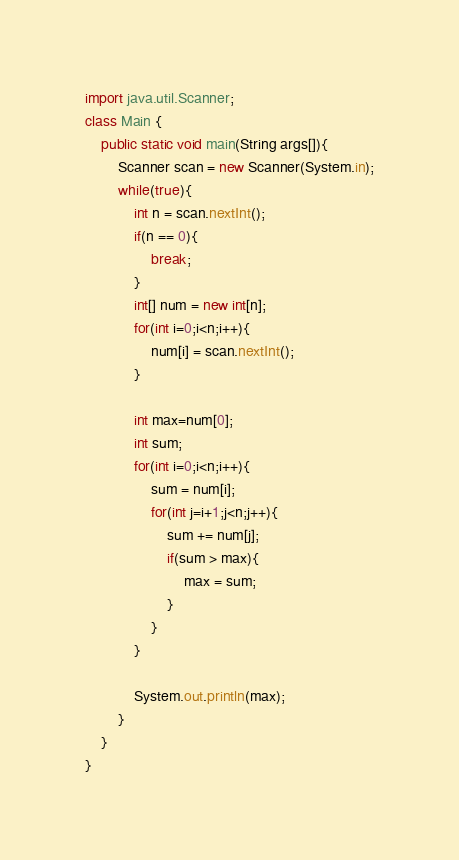<code> <loc_0><loc_0><loc_500><loc_500><_Java_>import java.util.Scanner;
class Main {
	public static void main(String args[]){
		Scanner scan = new Scanner(System.in);
		while(true){
			int n = scan.nextInt();
			if(n == 0){
				break;
			}
			int[] num = new int[n];
			for(int i=0;i<n;i++){
				num[i] = scan.nextInt();
			}
			
			int max=num[0];
			int sum;
			for(int i=0;i<n;i++){
				sum = num[i];
				for(int j=i+1;j<n;j++){
					sum += num[j];
					if(sum > max){
						max = sum;
					}
				}
			}
			
			System.out.println(max);
		}
	}
}</code> 